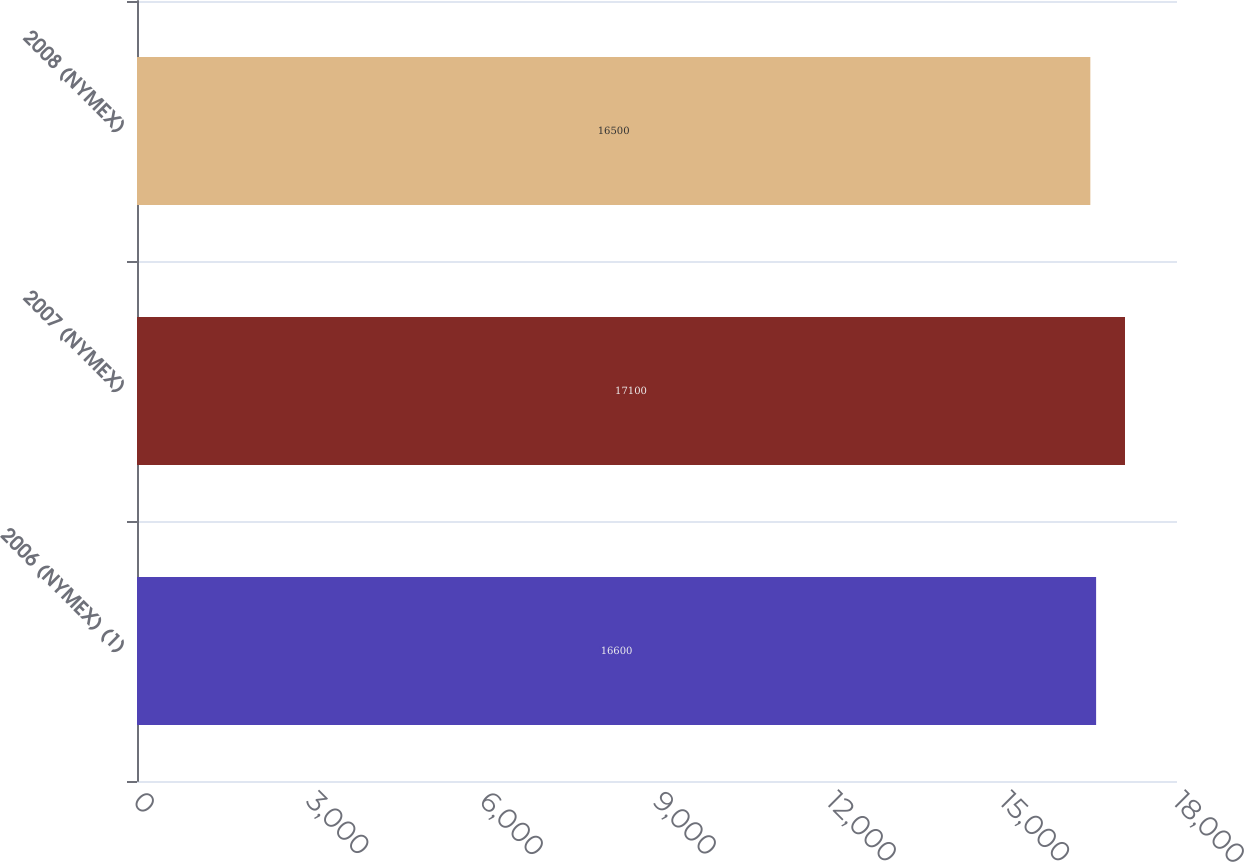<chart> <loc_0><loc_0><loc_500><loc_500><bar_chart><fcel>2006 (NYMEX) (1)<fcel>2007 (NYMEX)<fcel>2008 (NYMEX)<nl><fcel>16600<fcel>17100<fcel>16500<nl></chart> 